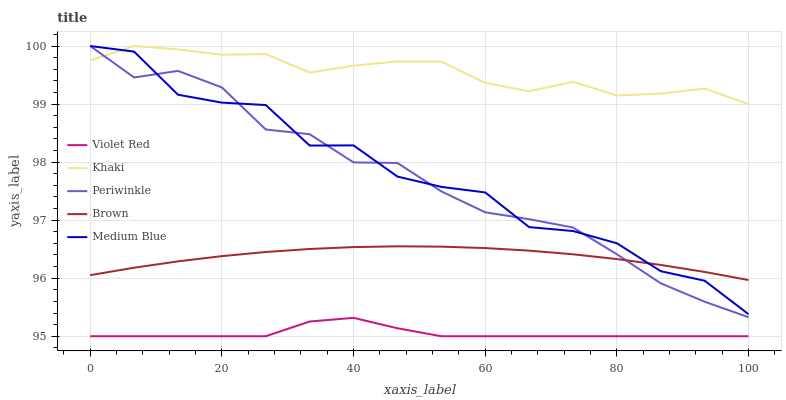Does Violet Red have the minimum area under the curve?
Answer yes or no. Yes. Does Khaki have the maximum area under the curve?
Answer yes or no. Yes. Does Khaki have the minimum area under the curve?
Answer yes or no. No. Does Violet Red have the maximum area under the curve?
Answer yes or no. No. Is Brown the smoothest?
Answer yes or no. Yes. Is Medium Blue the roughest?
Answer yes or no. Yes. Is Violet Red the smoothest?
Answer yes or no. No. Is Violet Red the roughest?
Answer yes or no. No. Does Violet Red have the lowest value?
Answer yes or no. Yes. Does Khaki have the lowest value?
Answer yes or no. No. Does Medium Blue have the highest value?
Answer yes or no. Yes. Does Violet Red have the highest value?
Answer yes or no. No. Is Violet Red less than Medium Blue?
Answer yes or no. Yes. Is Khaki greater than Violet Red?
Answer yes or no. Yes. Does Periwinkle intersect Medium Blue?
Answer yes or no. Yes. Is Periwinkle less than Medium Blue?
Answer yes or no. No. Is Periwinkle greater than Medium Blue?
Answer yes or no. No. Does Violet Red intersect Medium Blue?
Answer yes or no. No. 